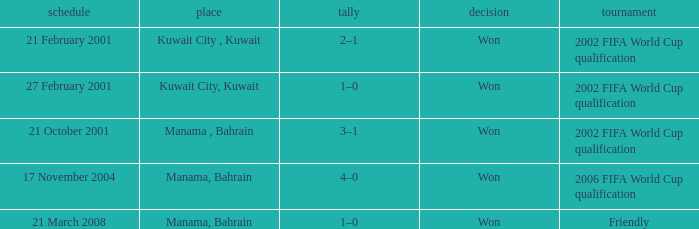On which date was the match in Manama, Bahrain? 21 October 2001, 17 November 2004, 21 March 2008. 